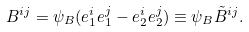Convert formula to latex. <formula><loc_0><loc_0><loc_500><loc_500>B ^ { i j } = \psi _ { B } ( e _ { 1 } ^ { i } e _ { 1 } ^ { j } - e _ { 2 } ^ { i } e _ { 2 } ^ { j } ) \equiv \psi _ { B } { \tilde { B } } ^ { i j } .</formula> 